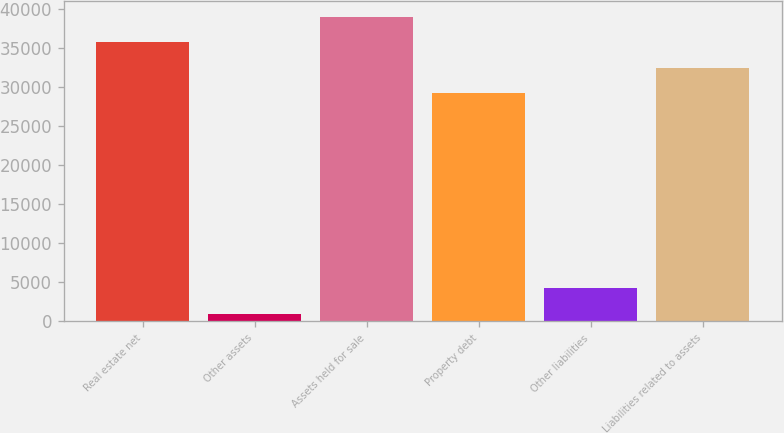Convert chart to OTSL. <chart><loc_0><loc_0><loc_500><loc_500><bar_chart><fcel>Real estate net<fcel>Other assets<fcel>Assets held for sale<fcel>Property debt<fcel>Other liabilities<fcel>Liabilities related to assets<nl><fcel>35731.6<fcel>953<fcel>39008.9<fcel>29177<fcel>4230.3<fcel>32454.3<nl></chart> 